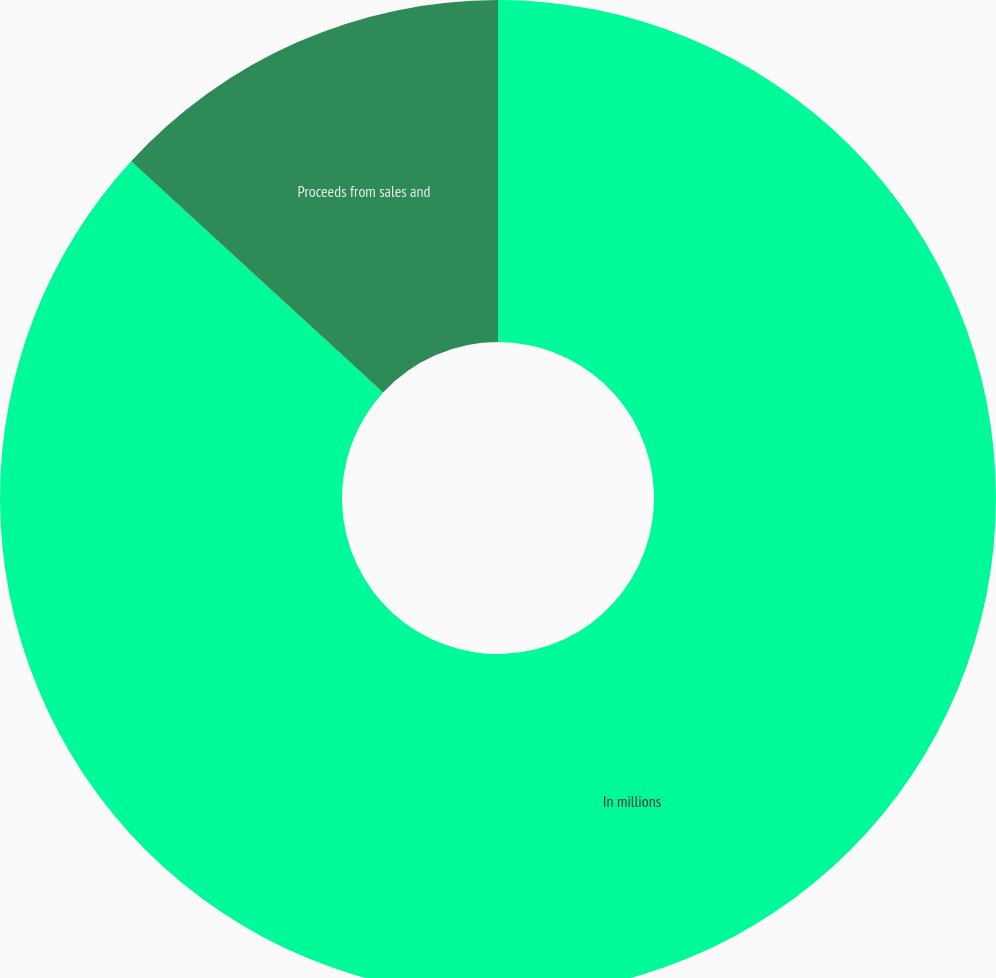Convert chart to OTSL. <chart><loc_0><loc_0><loc_500><loc_500><pie_chart><fcel>In millions<fcel>Proceeds from sales and<nl><fcel>86.82%<fcel>13.18%<nl></chart> 